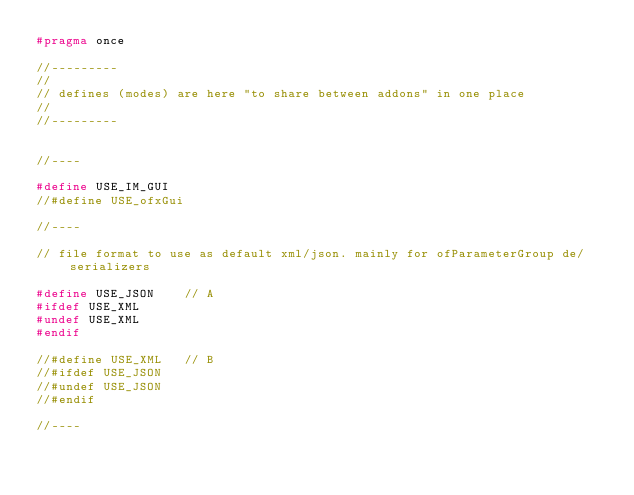<code> <loc_0><loc_0><loc_500><loc_500><_C_>#pragma once

//---------
//
// defines (modes) are here "to share between addons" in one place
//
//---------


//----

#define USE_IM_GUI
//#define USE_ofxGui

//----

// file format to use as default xml/json. mainly for ofParameterGroup de/serializers

#define USE_JSON	// A		
#ifdef USE_XML
#undef USE_XML
#endif

//#define USE_XML	// B
//#ifdef USE_JSON
//#undef USE_JSON
//#endif

//----
</code> 